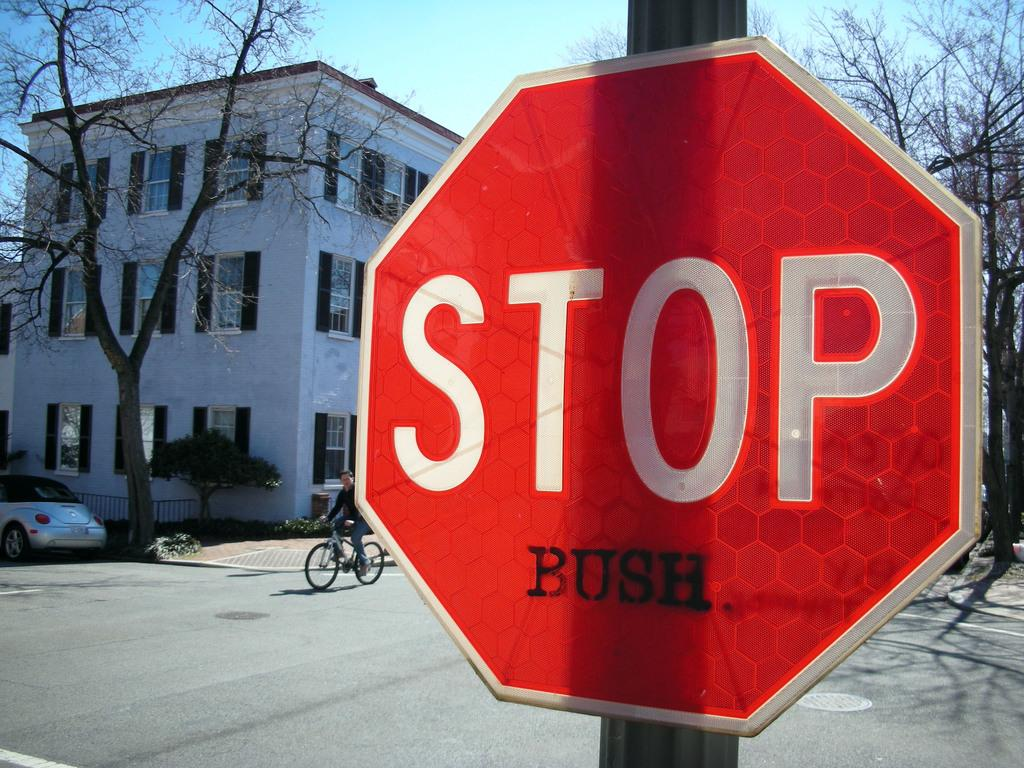<image>
Provide a brief description of the given image. a stop sign what the word bush on the bottom 